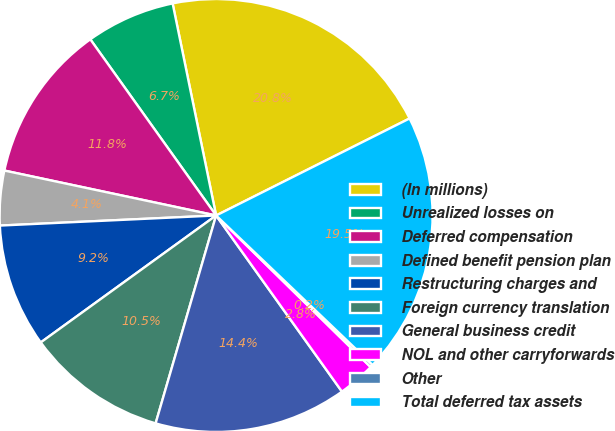Convert chart. <chart><loc_0><loc_0><loc_500><loc_500><pie_chart><fcel>(In millions)<fcel>Unrealized losses on<fcel>Deferred compensation<fcel>Defined benefit pension plan<fcel>Restructuring charges and<fcel>Foreign currency translation<fcel>General business credit<fcel>NOL and other carryforwards<fcel>Other<fcel>Total deferred tax assets<nl><fcel>20.82%<fcel>6.65%<fcel>11.8%<fcel>4.07%<fcel>9.23%<fcel>10.52%<fcel>14.38%<fcel>2.78%<fcel>0.21%<fcel>19.53%<nl></chart> 